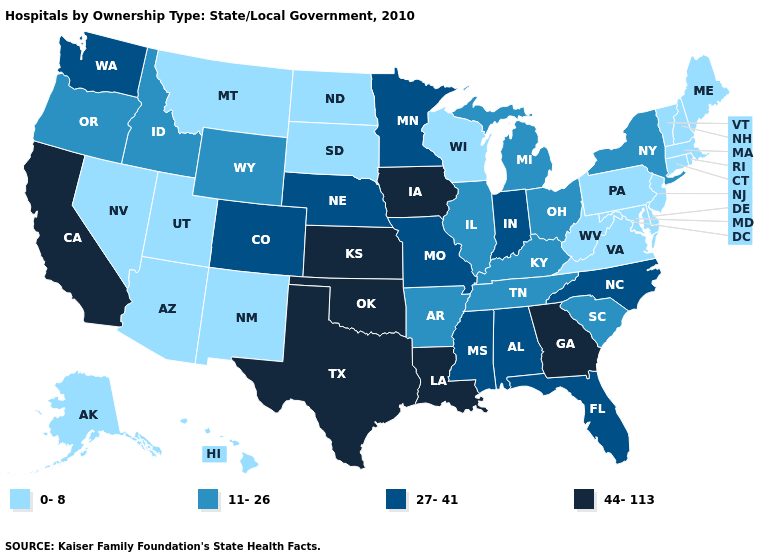What is the value of Pennsylvania?
Be succinct. 0-8. Does Pennsylvania have the same value as Delaware?
Keep it brief. Yes. Which states have the lowest value in the USA?
Answer briefly. Alaska, Arizona, Connecticut, Delaware, Hawaii, Maine, Maryland, Massachusetts, Montana, Nevada, New Hampshire, New Jersey, New Mexico, North Dakota, Pennsylvania, Rhode Island, South Dakota, Utah, Vermont, Virginia, West Virginia, Wisconsin. Name the states that have a value in the range 11-26?
Short answer required. Arkansas, Idaho, Illinois, Kentucky, Michigan, New York, Ohio, Oregon, South Carolina, Tennessee, Wyoming. Among the states that border Kentucky , which have the lowest value?
Answer briefly. Virginia, West Virginia. Name the states that have a value in the range 0-8?
Write a very short answer. Alaska, Arizona, Connecticut, Delaware, Hawaii, Maine, Maryland, Massachusetts, Montana, Nevada, New Hampshire, New Jersey, New Mexico, North Dakota, Pennsylvania, Rhode Island, South Dakota, Utah, Vermont, Virginia, West Virginia, Wisconsin. How many symbols are there in the legend?
Concise answer only. 4. Among the states that border Connecticut , which have the highest value?
Concise answer only. New York. Name the states that have a value in the range 27-41?
Be succinct. Alabama, Colorado, Florida, Indiana, Minnesota, Mississippi, Missouri, Nebraska, North Carolina, Washington. Does Minnesota have a lower value than Louisiana?
Answer briefly. Yes. Among the states that border Rhode Island , which have the highest value?
Short answer required. Connecticut, Massachusetts. What is the highest value in states that border Mississippi?
Short answer required. 44-113. Among the states that border Kansas , does Missouri have the lowest value?
Quick response, please. Yes. Does Kansas have the highest value in the MidWest?
Keep it brief. Yes. Name the states that have a value in the range 0-8?
Answer briefly. Alaska, Arizona, Connecticut, Delaware, Hawaii, Maine, Maryland, Massachusetts, Montana, Nevada, New Hampshire, New Jersey, New Mexico, North Dakota, Pennsylvania, Rhode Island, South Dakota, Utah, Vermont, Virginia, West Virginia, Wisconsin. 